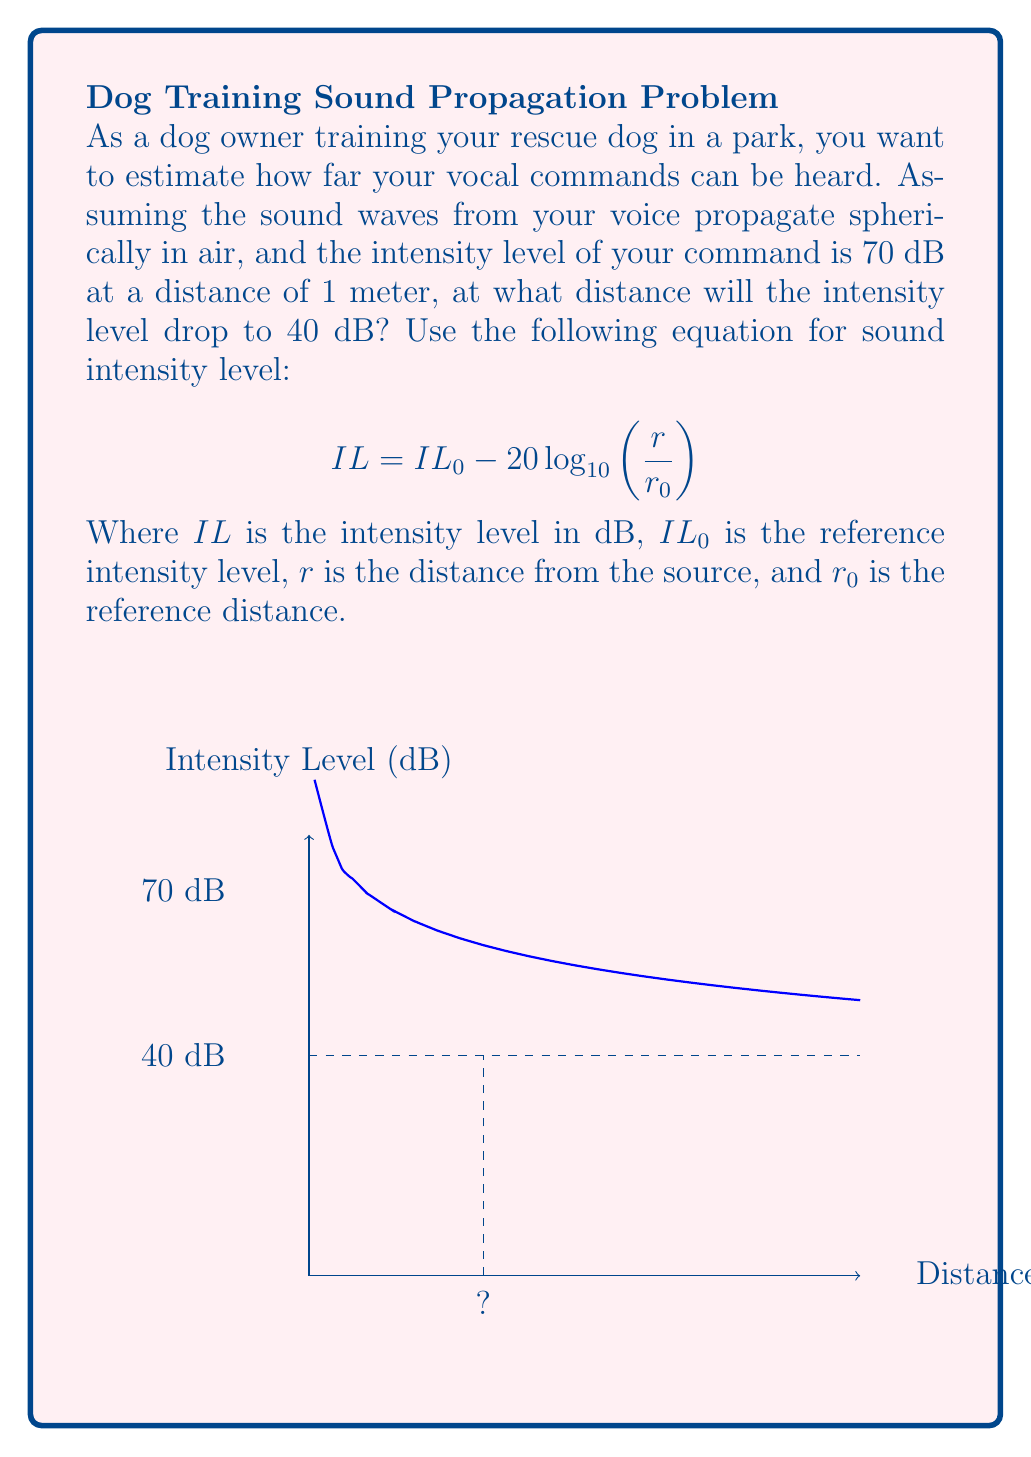Help me with this question. Let's approach this step-by-step:

1) We are given the equation:
   $$ IL = IL_0 - 20 \log_{10}\left(\frac{r}{r_0}\right) $$

2) We know:
   - $IL_0 = 70$ dB (at 1 meter)
   - $r_0 = 1$ meter
   - $IL = 40$ dB (the target intensity level)
   - We need to find $r$

3) Let's substitute these values into the equation:
   $$ 40 = 70 - 20 \log_{10}\left(\frac{r}{1}\right) $$

4) Simplify:
   $$ 40 = 70 - 20 \log_{10}(r) $$

5) Subtract 70 from both sides:
   $$ -30 = -20 \log_{10}(r) $$

6) Divide both sides by -20:
   $$ 1.5 = \log_{10}(r) $$

7) Take 10 to the power of both sides:
   $$ 10^{1.5} = r $$

8) Calculate:
   $$ r \approx 31.62 \text{ meters} $$

Therefore, the intensity level will drop to 40 dB at a distance of approximately 31.62 meters from the source.
Answer: 31.62 meters 